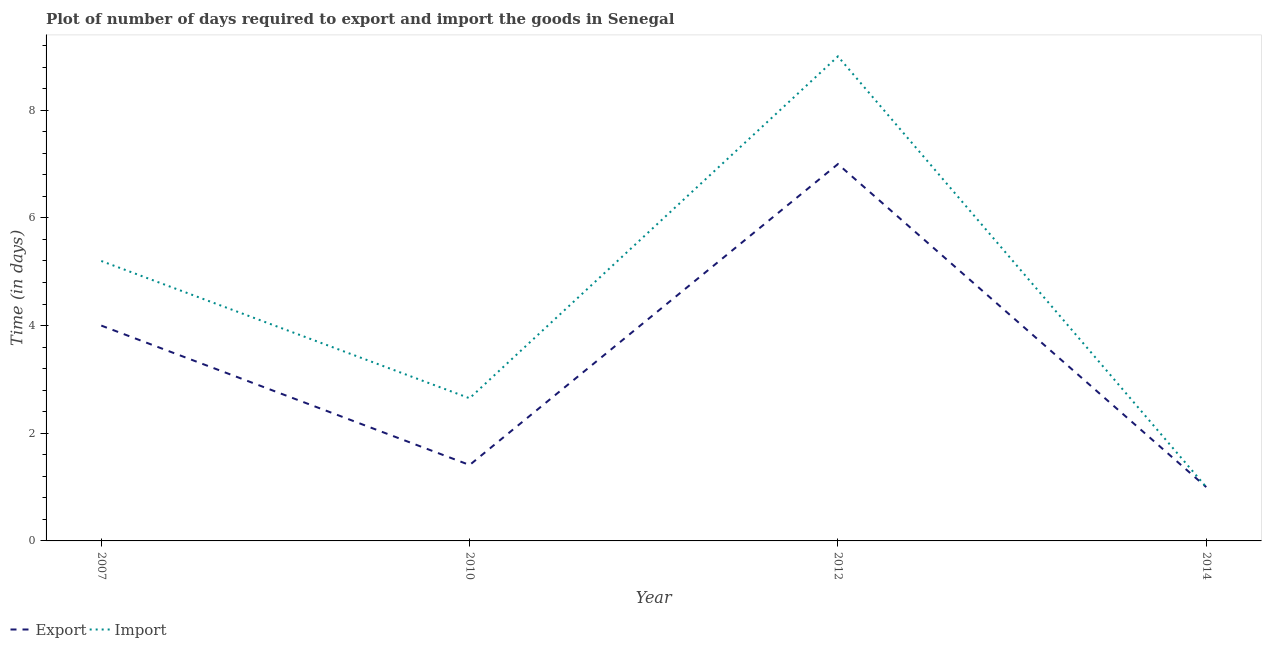Is the number of lines equal to the number of legend labels?
Offer a terse response. Yes. What is the time required to import in 2014?
Provide a succinct answer. 1. Across all years, what is the maximum time required to export?
Offer a terse response. 7. In which year was the time required to export maximum?
Keep it short and to the point. 2012. In which year was the time required to import minimum?
Provide a succinct answer. 2014. What is the total time required to export in the graph?
Provide a short and direct response. 13.41. What is the difference between the time required to import in 2010 and that in 2014?
Ensure brevity in your answer.  1.65. What is the difference between the time required to export in 2012 and the time required to import in 2007?
Provide a succinct answer. 1.8. What is the average time required to import per year?
Provide a short and direct response. 4.46. In the year 2010, what is the difference between the time required to export and time required to import?
Provide a short and direct response. -1.24. In how many years, is the time required to export greater than 0.8 days?
Provide a short and direct response. 4. What is the ratio of the time required to export in 2007 to that in 2012?
Make the answer very short. 0.57. Is the time required to import in 2010 less than that in 2012?
Provide a succinct answer. Yes. Is the difference between the time required to import in 2010 and 2012 greater than the difference between the time required to export in 2010 and 2012?
Make the answer very short. No. In how many years, is the time required to export greater than the average time required to export taken over all years?
Provide a short and direct response. 2. Does the time required to export monotonically increase over the years?
Your answer should be very brief. No. Is the time required to import strictly greater than the time required to export over the years?
Ensure brevity in your answer.  No. Is the time required to export strictly less than the time required to import over the years?
Your response must be concise. No. How many lines are there?
Offer a very short reply. 2. How many years are there in the graph?
Offer a very short reply. 4. What is the difference between two consecutive major ticks on the Y-axis?
Offer a very short reply. 2. Are the values on the major ticks of Y-axis written in scientific E-notation?
Offer a terse response. No. Does the graph contain any zero values?
Offer a terse response. No. Where does the legend appear in the graph?
Offer a very short reply. Bottom left. How are the legend labels stacked?
Make the answer very short. Horizontal. What is the title of the graph?
Your answer should be compact. Plot of number of days required to export and import the goods in Senegal. Does "Pregnant women" appear as one of the legend labels in the graph?
Offer a terse response. No. What is the label or title of the X-axis?
Offer a terse response. Year. What is the label or title of the Y-axis?
Give a very brief answer. Time (in days). What is the Time (in days) in Import in 2007?
Provide a succinct answer. 5.2. What is the Time (in days) of Export in 2010?
Your answer should be compact. 1.41. What is the Time (in days) of Import in 2010?
Your response must be concise. 2.65. What is the Time (in days) of Export in 2012?
Offer a terse response. 7. What is the Time (in days) of Import in 2012?
Give a very brief answer. 9. What is the Time (in days) in Import in 2014?
Ensure brevity in your answer.  1. Across all years, what is the maximum Time (in days) in Import?
Your answer should be very brief. 9. Across all years, what is the minimum Time (in days) in Import?
Provide a succinct answer. 1. What is the total Time (in days) in Export in the graph?
Your response must be concise. 13.41. What is the total Time (in days) of Import in the graph?
Your answer should be very brief. 17.85. What is the difference between the Time (in days) in Export in 2007 and that in 2010?
Your answer should be very brief. 2.59. What is the difference between the Time (in days) of Import in 2007 and that in 2010?
Provide a succinct answer. 2.55. What is the difference between the Time (in days) in Export in 2007 and that in 2014?
Make the answer very short. 3. What is the difference between the Time (in days) of Import in 2007 and that in 2014?
Ensure brevity in your answer.  4.2. What is the difference between the Time (in days) of Export in 2010 and that in 2012?
Make the answer very short. -5.59. What is the difference between the Time (in days) in Import in 2010 and that in 2012?
Keep it short and to the point. -6.35. What is the difference between the Time (in days) of Export in 2010 and that in 2014?
Make the answer very short. 0.41. What is the difference between the Time (in days) in Import in 2010 and that in 2014?
Offer a very short reply. 1.65. What is the difference between the Time (in days) of Export in 2012 and that in 2014?
Your answer should be very brief. 6. What is the difference between the Time (in days) in Import in 2012 and that in 2014?
Make the answer very short. 8. What is the difference between the Time (in days) of Export in 2007 and the Time (in days) of Import in 2010?
Make the answer very short. 1.35. What is the difference between the Time (in days) in Export in 2010 and the Time (in days) in Import in 2012?
Your response must be concise. -7.59. What is the difference between the Time (in days) in Export in 2010 and the Time (in days) in Import in 2014?
Your response must be concise. 0.41. What is the average Time (in days) of Export per year?
Offer a very short reply. 3.35. What is the average Time (in days) of Import per year?
Ensure brevity in your answer.  4.46. In the year 2010, what is the difference between the Time (in days) of Export and Time (in days) of Import?
Ensure brevity in your answer.  -1.24. In the year 2012, what is the difference between the Time (in days) of Export and Time (in days) of Import?
Provide a short and direct response. -2. What is the ratio of the Time (in days) in Export in 2007 to that in 2010?
Provide a short and direct response. 2.84. What is the ratio of the Time (in days) of Import in 2007 to that in 2010?
Your response must be concise. 1.96. What is the ratio of the Time (in days) in Export in 2007 to that in 2012?
Provide a succinct answer. 0.57. What is the ratio of the Time (in days) of Import in 2007 to that in 2012?
Your answer should be very brief. 0.58. What is the ratio of the Time (in days) in Export in 2007 to that in 2014?
Provide a succinct answer. 4. What is the ratio of the Time (in days) in Export in 2010 to that in 2012?
Your response must be concise. 0.2. What is the ratio of the Time (in days) in Import in 2010 to that in 2012?
Keep it short and to the point. 0.29. What is the ratio of the Time (in days) in Export in 2010 to that in 2014?
Your answer should be compact. 1.41. What is the ratio of the Time (in days) of Import in 2010 to that in 2014?
Ensure brevity in your answer.  2.65. What is the ratio of the Time (in days) of Export in 2012 to that in 2014?
Keep it short and to the point. 7. What is the difference between the highest and the second highest Time (in days) of Import?
Your response must be concise. 3.8. What is the difference between the highest and the lowest Time (in days) in Import?
Provide a succinct answer. 8. 